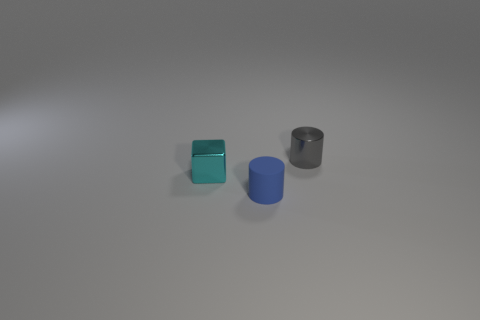Is the number of gray cylinders that are in front of the tiny blue cylinder less than the number of blue matte cylinders that are behind the small gray cylinder?
Your answer should be compact. No. Is the size of the object in front of the metallic block the same as the tiny cyan thing?
Your response must be concise. Yes. What is the shape of the thing that is right of the small blue object?
Keep it short and to the point. Cylinder. Are there more small gray metal spheres than small gray metal cylinders?
Your response must be concise. No. There is a small metal object on the left side of the small gray shiny cylinder; is it the same color as the matte cylinder?
Your answer should be very brief. No. How many objects are either tiny metallic things to the right of the cyan metal block or tiny cylinders that are on the left side of the gray metallic object?
Give a very brief answer. 2. How many cylinders are both in front of the metal cylinder and behind the tiny blue object?
Provide a short and direct response. 0. Is the tiny blue cylinder made of the same material as the gray cylinder?
Make the answer very short. No. The small shiny thing that is on the left side of the small cylinder behind the cylinder left of the small shiny cylinder is what shape?
Make the answer very short. Cube. What material is the object that is both to the right of the cyan metallic cube and on the left side of the gray shiny cylinder?
Offer a terse response. Rubber. 